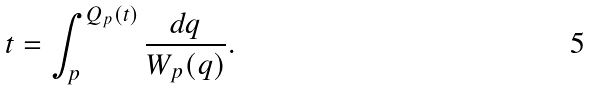<formula> <loc_0><loc_0><loc_500><loc_500>t = \int _ { p } ^ { Q _ { p } ( t ) } \frac { \text  d q}{W_{p} ( q ) } .</formula> 